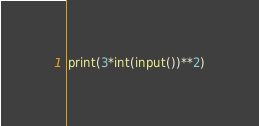<code> <loc_0><loc_0><loc_500><loc_500><_Python_>print(3*int(input())**2)</code> 